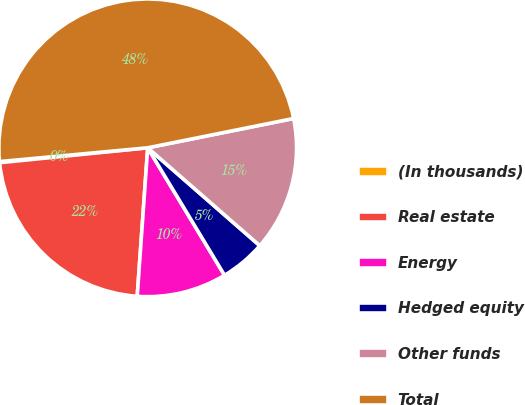<chart> <loc_0><loc_0><loc_500><loc_500><pie_chart><fcel>(In thousands)<fcel>Real estate<fcel>Energy<fcel>Hedged equity<fcel>Other funds<fcel>Total<nl><fcel>0.12%<fcel>22.28%<fcel>9.76%<fcel>4.94%<fcel>14.58%<fcel>48.32%<nl></chart> 